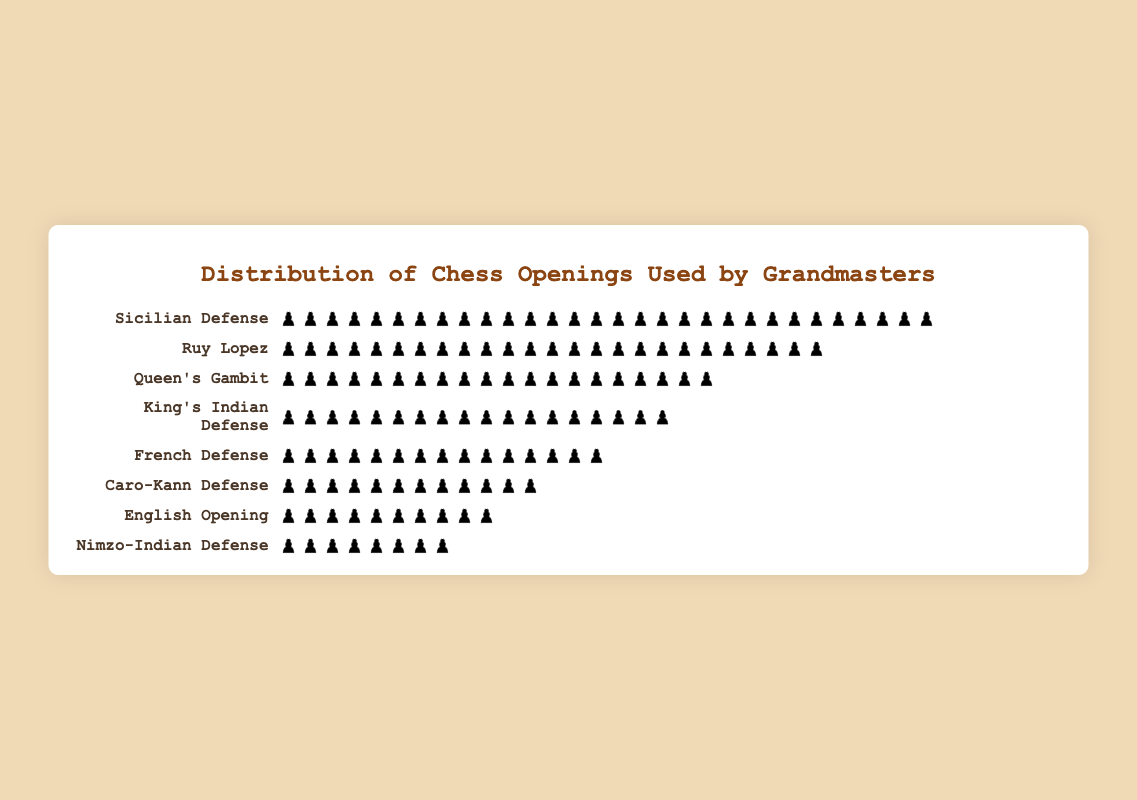What is the most used chess opening by grandmasters? The opening with the highest count of pieces is the Sicilian Defense with 30 pieces.
Answer: Sicilian Defense Which chess opening is used least frequently by grandmasters? The opening with the lowest count of pieces is the Nimzo-Indian Defense with 8 pieces.
Answer: Nimzo-Indian Defense How many pieces represent the Ruy Lopez opening? Count the number of pieces next to the Ruy Lopez label on the plot.
Answer: 25 What is the total count of pieces for the French Defense and Caro-Kann Defense combined? Add the counts for French Defense (15 pieces) and Caro-Kann Defense (12 pieces): 15 + 12 = 27 pieces.
Answer: 27 Which openings have counts greater than 20? Look for openings with more than 20 pieces. They are Sicilian Defense (30), Ruy Lopez (25), and Queen's Gambit (20).
Answer: Sicilian Defense, Ruy Lopez, Queen's Gambit What is the difference in the count of pieces between King's Indian Defense and English Opening? Subtract the count of English Opening (10 pieces) from King's Indian Defense (18 pieces): 18 - 10 = 8 pieces.
Answer: 8 How many different chess openings are displayed in the plot? Count the number of different opening names in the plot.
Answer: 8 Is the Ruy Lopez opening used more frequently than the Queen's Gambit? Compare the counts for Ruy Lopez (25 pieces) and Queen's Gambit (20 pieces).
Answer: Yes What is the average count of pieces for the openings displayed? Add up all the piece counts and divide by the number of openings. Sum: 30 + 15 + 25 + 20 + 18 + 12 + 10 + 8 = 138, Number of openings = 8, Average = 138 / 8 = 17.25 pieces.
Answer: 17.25 Which opening has a count closest to the average count of pieces? The average count is 17.25. Compare the counts to find the closest value: 18 (King's Indian Defense is the closest with 18 pieces).
Answer: King's Indian Defense 